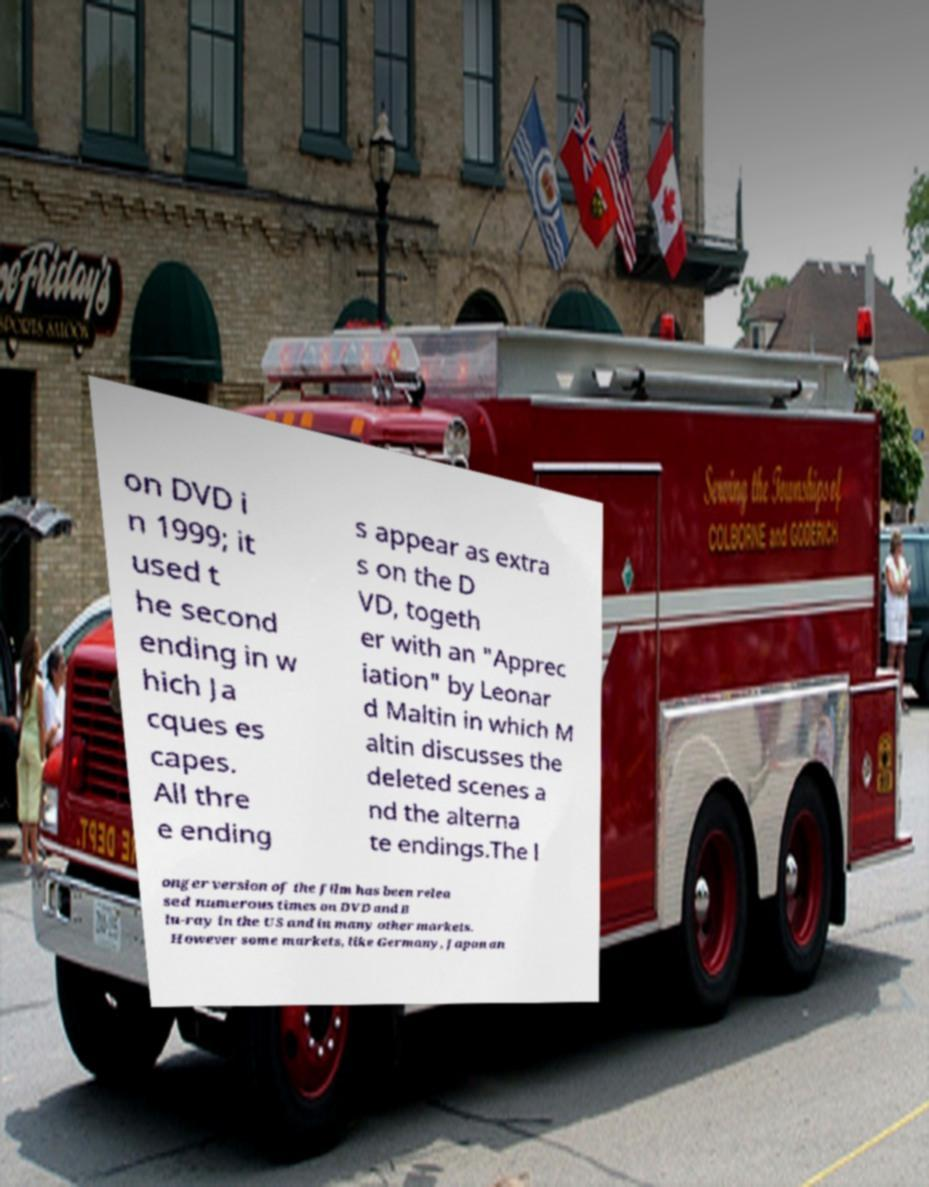Could you assist in decoding the text presented in this image and type it out clearly? on DVD i n 1999; it used t he second ending in w hich Ja cques es capes. All thre e ending s appear as extra s on the D VD, togeth er with an "Apprec iation" by Leonar d Maltin in which M altin discusses the deleted scenes a nd the alterna te endings.The l onger version of the film has been relea sed numerous times on DVD and B lu-ray in the US and in many other markets. However some markets, like Germany, Japan an 